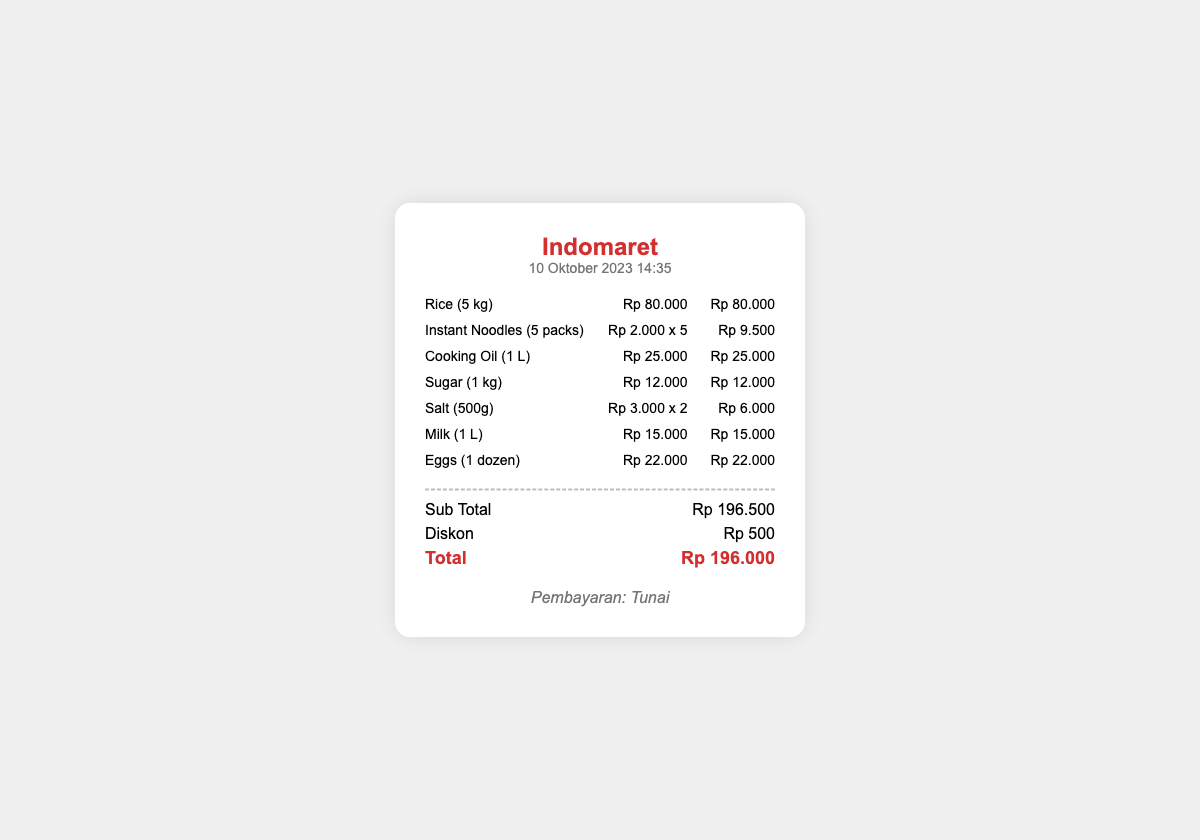What is the date of the receipt? The receipt states the date of the transaction as "10 Oktober 2023".
Answer: 10 Oktober 2023 What is the total amount after discount? The total amount after applying the discount is given as "Rp 196.000".
Answer: Rp 196.000 How much did the Rice cost? The cost of Rice is listed as "Rp 80.000".
Answer: Rp 80.000 What discount was applied? The document shows a discount of "Rp 500" was applied.
Answer: Rp 500 How many packs of Instant Noodles were purchased? The receipt indicates that "5 packs" of Instant Noodles were purchased.
Answer: 5 packs What was the payment method? The receipt specifies that the payment method was "Tunai".
Answer: Tunai What is the subtotal before discount? The subtotal prior to discount is given as "Rp 196.500".
Answer: Rp 196.500 How much did the Salt cost per item? The cost per item for Salt is shown as "Rp 3.000".
Answer: Rp 3.000 Which store issued this receipt? The receipt indicates that the store is "Indomaret".
Answer: Indomaret 